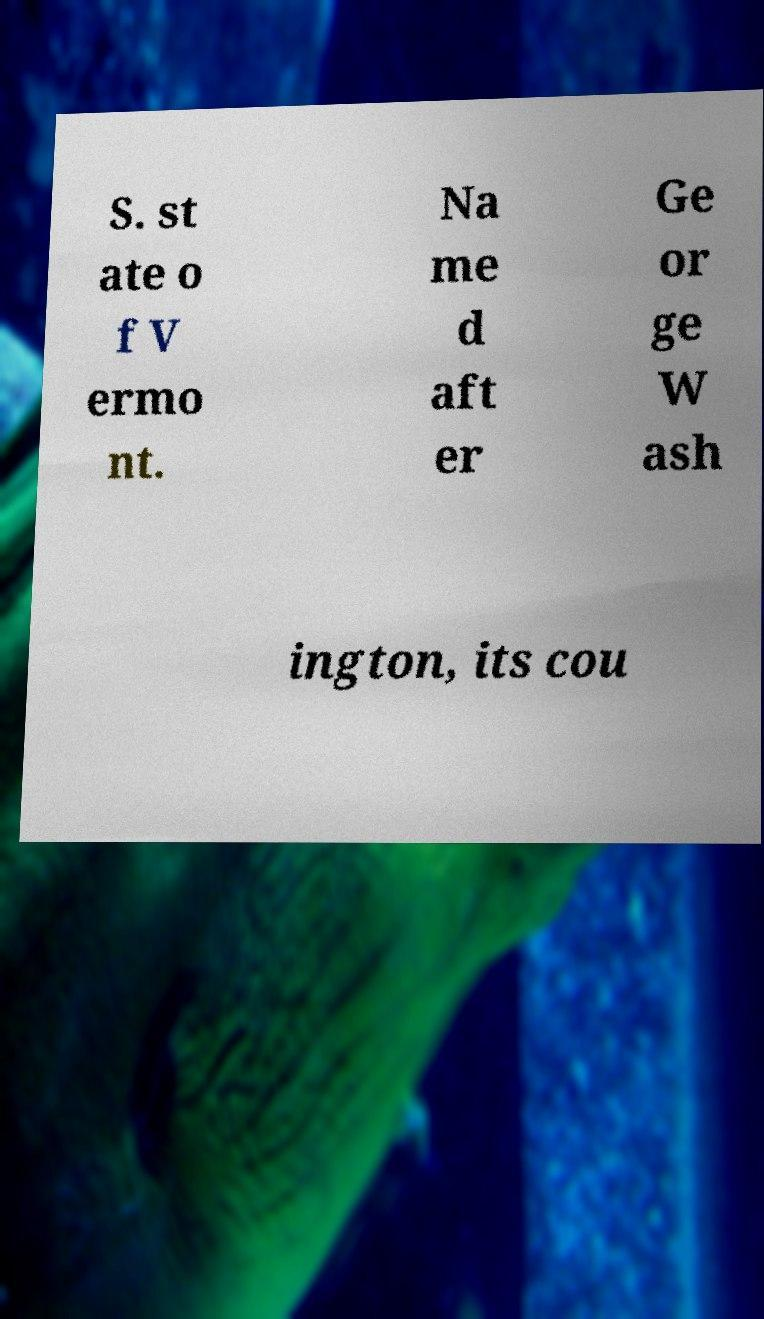Could you extract and type out the text from this image? S. st ate o f V ermo nt. Na me d aft er Ge or ge W ash ington, its cou 